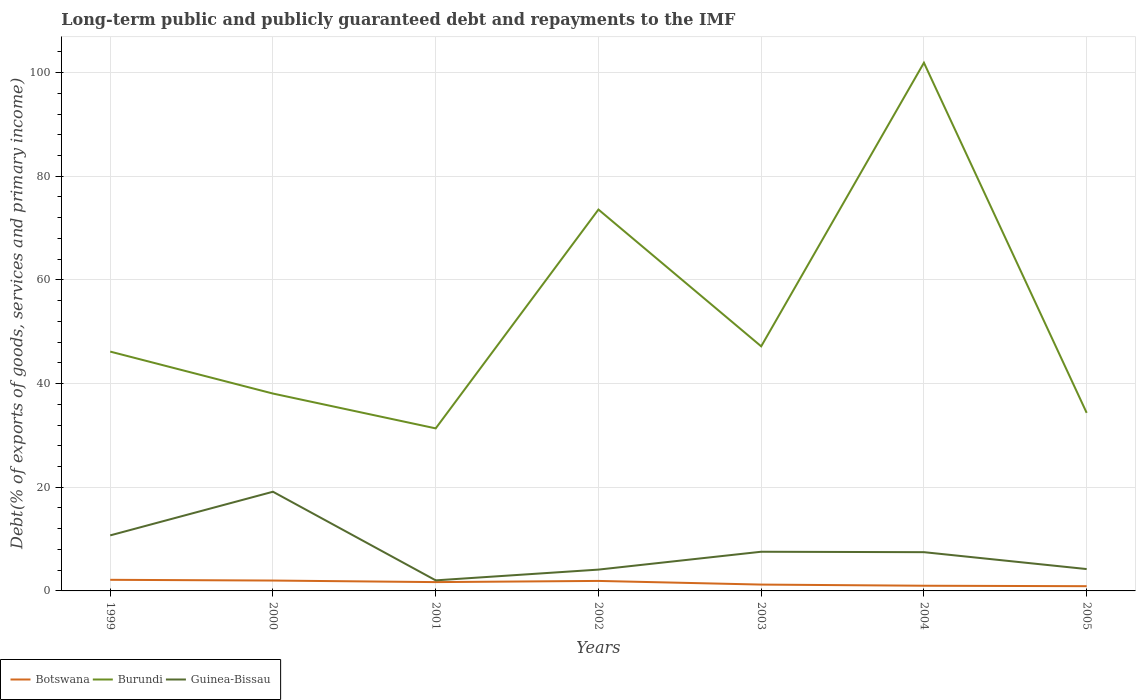Is the number of lines equal to the number of legend labels?
Keep it short and to the point. Yes. Across all years, what is the maximum debt and repayments in Burundi?
Keep it short and to the point. 31.35. In which year was the debt and repayments in Guinea-Bissau maximum?
Provide a short and direct response. 2001. What is the total debt and repayments in Burundi in the graph?
Your answer should be compact. 67.54. What is the difference between the highest and the second highest debt and repayments in Botswana?
Give a very brief answer. 1.23. What is the difference between the highest and the lowest debt and repayments in Burundi?
Keep it short and to the point. 2. What is the difference between two consecutive major ticks on the Y-axis?
Offer a terse response. 20. Where does the legend appear in the graph?
Provide a short and direct response. Bottom left. How many legend labels are there?
Ensure brevity in your answer.  3. What is the title of the graph?
Provide a succinct answer. Long-term public and publicly guaranteed debt and repayments to the IMF. Does "St. Vincent and the Grenadines" appear as one of the legend labels in the graph?
Your response must be concise. No. What is the label or title of the Y-axis?
Provide a short and direct response. Debt(% of exports of goods, services and primary income). What is the Debt(% of exports of goods, services and primary income) in Botswana in 1999?
Give a very brief answer. 2.14. What is the Debt(% of exports of goods, services and primary income) of Burundi in 1999?
Keep it short and to the point. 46.17. What is the Debt(% of exports of goods, services and primary income) in Guinea-Bissau in 1999?
Provide a short and direct response. 10.71. What is the Debt(% of exports of goods, services and primary income) in Botswana in 2000?
Give a very brief answer. 2. What is the Debt(% of exports of goods, services and primary income) in Burundi in 2000?
Give a very brief answer. 38.07. What is the Debt(% of exports of goods, services and primary income) of Guinea-Bissau in 2000?
Offer a very short reply. 19.13. What is the Debt(% of exports of goods, services and primary income) of Botswana in 2001?
Your response must be concise. 1.7. What is the Debt(% of exports of goods, services and primary income) of Burundi in 2001?
Your response must be concise. 31.35. What is the Debt(% of exports of goods, services and primary income) in Guinea-Bissau in 2001?
Offer a very short reply. 2.04. What is the Debt(% of exports of goods, services and primary income) of Botswana in 2002?
Your response must be concise. 1.93. What is the Debt(% of exports of goods, services and primary income) of Burundi in 2002?
Provide a short and direct response. 73.57. What is the Debt(% of exports of goods, services and primary income) of Guinea-Bissau in 2002?
Provide a succinct answer. 4.11. What is the Debt(% of exports of goods, services and primary income) of Botswana in 2003?
Your answer should be very brief. 1.22. What is the Debt(% of exports of goods, services and primary income) in Burundi in 2003?
Provide a short and direct response. 47.19. What is the Debt(% of exports of goods, services and primary income) in Guinea-Bissau in 2003?
Give a very brief answer. 7.56. What is the Debt(% of exports of goods, services and primary income) in Botswana in 2004?
Keep it short and to the point. 1. What is the Debt(% of exports of goods, services and primary income) of Burundi in 2004?
Make the answer very short. 101.89. What is the Debt(% of exports of goods, services and primary income) in Guinea-Bissau in 2004?
Your answer should be very brief. 7.47. What is the Debt(% of exports of goods, services and primary income) in Botswana in 2005?
Give a very brief answer. 0.91. What is the Debt(% of exports of goods, services and primary income) in Burundi in 2005?
Give a very brief answer. 34.35. What is the Debt(% of exports of goods, services and primary income) of Guinea-Bissau in 2005?
Provide a succinct answer. 4.22. Across all years, what is the maximum Debt(% of exports of goods, services and primary income) of Botswana?
Ensure brevity in your answer.  2.14. Across all years, what is the maximum Debt(% of exports of goods, services and primary income) of Burundi?
Your response must be concise. 101.89. Across all years, what is the maximum Debt(% of exports of goods, services and primary income) of Guinea-Bissau?
Your response must be concise. 19.13. Across all years, what is the minimum Debt(% of exports of goods, services and primary income) of Botswana?
Your answer should be very brief. 0.91. Across all years, what is the minimum Debt(% of exports of goods, services and primary income) in Burundi?
Keep it short and to the point. 31.35. Across all years, what is the minimum Debt(% of exports of goods, services and primary income) of Guinea-Bissau?
Your response must be concise. 2.04. What is the total Debt(% of exports of goods, services and primary income) of Botswana in the graph?
Your response must be concise. 10.91. What is the total Debt(% of exports of goods, services and primary income) of Burundi in the graph?
Your answer should be very brief. 372.59. What is the total Debt(% of exports of goods, services and primary income) of Guinea-Bissau in the graph?
Provide a short and direct response. 55.25. What is the difference between the Debt(% of exports of goods, services and primary income) in Botswana in 1999 and that in 2000?
Make the answer very short. 0.14. What is the difference between the Debt(% of exports of goods, services and primary income) of Burundi in 1999 and that in 2000?
Keep it short and to the point. 8.09. What is the difference between the Debt(% of exports of goods, services and primary income) of Guinea-Bissau in 1999 and that in 2000?
Offer a terse response. -8.42. What is the difference between the Debt(% of exports of goods, services and primary income) in Botswana in 1999 and that in 2001?
Offer a terse response. 0.44. What is the difference between the Debt(% of exports of goods, services and primary income) in Burundi in 1999 and that in 2001?
Make the answer very short. 14.81. What is the difference between the Debt(% of exports of goods, services and primary income) in Guinea-Bissau in 1999 and that in 2001?
Offer a terse response. 8.68. What is the difference between the Debt(% of exports of goods, services and primary income) in Botswana in 1999 and that in 2002?
Provide a short and direct response. 0.21. What is the difference between the Debt(% of exports of goods, services and primary income) of Burundi in 1999 and that in 2002?
Keep it short and to the point. -27.4. What is the difference between the Debt(% of exports of goods, services and primary income) of Guinea-Bissau in 1999 and that in 2002?
Offer a very short reply. 6.6. What is the difference between the Debt(% of exports of goods, services and primary income) in Botswana in 1999 and that in 2003?
Offer a very short reply. 0.92. What is the difference between the Debt(% of exports of goods, services and primary income) of Burundi in 1999 and that in 2003?
Provide a short and direct response. -1.02. What is the difference between the Debt(% of exports of goods, services and primary income) in Guinea-Bissau in 1999 and that in 2003?
Offer a very short reply. 3.16. What is the difference between the Debt(% of exports of goods, services and primary income) of Botswana in 1999 and that in 2004?
Ensure brevity in your answer.  1.14. What is the difference between the Debt(% of exports of goods, services and primary income) of Burundi in 1999 and that in 2004?
Your answer should be very brief. -55.72. What is the difference between the Debt(% of exports of goods, services and primary income) of Guinea-Bissau in 1999 and that in 2004?
Your answer should be very brief. 3.24. What is the difference between the Debt(% of exports of goods, services and primary income) of Botswana in 1999 and that in 2005?
Provide a short and direct response. 1.23. What is the difference between the Debt(% of exports of goods, services and primary income) in Burundi in 1999 and that in 2005?
Your answer should be compact. 11.82. What is the difference between the Debt(% of exports of goods, services and primary income) in Guinea-Bissau in 1999 and that in 2005?
Your answer should be compact. 6.5. What is the difference between the Debt(% of exports of goods, services and primary income) of Botswana in 2000 and that in 2001?
Provide a succinct answer. 0.3. What is the difference between the Debt(% of exports of goods, services and primary income) of Burundi in 2000 and that in 2001?
Your answer should be compact. 6.72. What is the difference between the Debt(% of exports of goods, services and primary income) of Guinea-Bissau in 2000 and that in 2001?
Your answer should be very brief. 17.1. What is the difference between the Debt(% of exports of goods, services and primary income) in Botswana in 2000 and that in 2002?
Your answer should be compact. 0.07. What is the difference between the Debt(% of exports of goods, services and primary income) of Burundi in 2000 and that in 2002?
Offer a terse response. -35.5. What is the difference between the Debt(% of exports of goods, services and primary income) of Guinea-Bissau in 2000 and that in 2002?
Your answer should be compact. 15.02. What is the difference between the Debt(% of exports of goods, services and primary income) in Botswana in 2000 and that in 2003?
Offer a terse response. 0.78. What is the difference between the Debt(% of exports of goods, services and primary income) of Burundi in 2000 and that in 2003?
Provide a short and direct response. -9.11. What is the difference between the Debt(% of exports of goods, services and primary income) in Guinea-Bissau in 2000 and that in 2003?
Provide a succinct answer. 11.58. What is the difference between the Debt(% of exports of goods, services and primary income) in Botswana in 2000 and that in 2004?
Your answer should be compact. 1. What is the difference between the Debt(% of exports of goods, services and primary income) in Burundi in 2000 and that in 2004?
Your response must be concise. -63.82. What is the difference between the Debt(% of exports of goods, services and primary income) of Guinea-Bissau in 2000 and that in 2004?
Provide a short and direct response. 11.66. What is the difference between the Debt(% of exports of goods, services and primary income) in Botswana in 2000 and that in 2005?
Provide a succinct answer. 1.09. What is the difference between the Debt(% of exports of goods, services and primary income) in Burundi in 2000 and that in 2005?
Provide a short and direct response. 3.72. What is the difference between the Debt(% of exports of goods, services and primary income) of Guinea-Bissau in 2000 and that in 2005?
Your answer should be very brief. 14.92. What is the difference between the Debt(% of exports of goods, services and primary income) of Botswana in 2001 and that in 2002?
Your answer should be very brief. -0.23. What is the difference between the Debt(% of exports of goods, services and primary income) in Burundi in 2001 and that in 2002?
Provide a succinct answer. -42.22. What is the difference between the Debt(% of exports of goods, services and primary income) in Guinea-Bissau in 2001 and that in 2002?
Ensure brevity in your answer.  -2.07. What is the difference between the Debt(% of exports of goods, services and primary income) in Botswana in 2001 and that in 2003?
Your response must be concise. 0.48. What is the difference between the Debt(% of exports of goods, services and primary income) of Burundi in 2001 and that in 2003?
Offer a terse response. -15.83. What is the difference between the Debt(% of exports of goods, services and primary income) in Guinea-Bissau in 2001 and that in 2003?
Your answer should be compact. -5.52. What is the difference between the Debt(% of exports of goods, services and primary income) in Botswana in 2001 and that in 2004?
Make the answer very short. 0.7. What is the difference between the Debt(% of exports of goods, services and primary income) of Burundi in 2001 and that in 2004?
Keep it short and to the point. -70.53. What is the difference between the Debt(% of exports of goods, services and primary income) of Guinea-Bissau in 2001 and that in 2004?
Keep it short and to the point. -5.44. What is the difference between the Debt(% of exports of goods, services and primary income) of Botswana in 2001 and that in 2005?
Provide a short and direct response. 0.79. What is the difference between the Debt(% of exports of goods, services and primary income) in Burundi in 2001 and that in 2005?
Offer a very short reply. -2.99. What is the difference between the Debt(% of exports of goods, services and primary income) of Guinea-Bissau in 2001 and that in 2005?
Your answer should be very brief. -2.18. What is the difference between the Debt(% of exports of goods, services and primary income) of Botswana in 2002 and that in 2003?
Offer a very short reply. 0.71. What is the difference between the Debt(% of exports of goods, services and primary income) of Burundi in 2002 and that in 2003?
Give a very brief answer. 26.39. What is the difference between the Debt(% of exports of goods, services and primary income) in Guinea-Bissau in 2002 and that in 2003?
Your response must be concise. -3.45. What is the difference between the Debt(% of exports of goods, services and primary income) of Botswana in 2002 and that in 2004?
Your answer should be very brief. 0.93. What is the difference between the Debt(% of exports of goods, services and primary income) of Burundi in 2002 and that in 2004?
Your answer should be very brief. -28.32. What is the difference between the Debt(% of exports of goods, services and primary income) of Guinea-Bissau in 2002 and that in 2004?
Provide a succinct answer. -3.36. What is the difference between the Debt(% of exports of goods, services and primary income) in Botswana in 2002 and that in 2005?
Make the answer very short. 1.02. What is the difference between the Debt(% of exports of goods, services and primary income) in Burundi in 2002 and that in 2005?
Your answer should be compact. 39.22. What is the difference between the Debt(% of exports of goods, services and primary income) in Guinea-Bissau in 2002 and that in 2005?
Your answer should be compact. -0.1. What is the difference between the Debt(% of exports of goods, services and primary income) in Botswana in 2003 and that in 2004?
Your answer should be very brief. 0.22. What is the difference between the Debt(% of exports of goods, services and primary income) of Burundi in 2003 and that in 2004?
Your answer should be very brief. -54.7. What is the difference between the Debt(% of exports of goods, services and primary income) of Guinea-Bissau in 2003 and that in 2004?
Offer a terse response. 0.08. What is the difference between the Debt(% of exports of goods, services and primary income) of Botswana in 2003 and that in 2005?
Ensure brevity in your answer.  0.31. What is the difference between the Debt(% of exports of goods, services and primary income) in Burundi in 2003 and that in 2005?
Offer a very short reply. 12.84. What is the difference between the Debt(% of exports of goods, services and primary income) in Guinea-Bissau in 2003 and that in 2005?
Your answer should be very brief. 3.34. What is the difference between the Debt(% of exports of goods, services and primary income) in Botswana in 2004 and that in 2005?
Keep it short and to the point. 0.09. What is the difference between the Debt(% of exports of goods, services and primary income) of Burundi in 2004 and that in 2005?
Offer a very short reply. 67.54. What is the difference between the Debt(% of exports of goods, services and primary income) in Guinea-Bissau in 2004 and that in 2005?
Your response must be concise. 3.26. What is the difference between the Debt(% of exports of goods, services and primary income) of Botswana in 1999 and the Debt(% of exports of goods, services and primary income) of Burundi in 2000?
Give a very brief answer. -35.93. What is the difference between the Debt(% of exports of goods, services and primary income) in Botswana in 1999 and the Debt(% of exports of goods, services and primary income) in Guinea-Bissau in 2000?
Your answer should be compact. -16.99. What is the difference between the Debt(% of exports of goods, services and primary income) of Burundi in 1999 and the Debt(% of exports of goods, services and primary income) of Guinea-Bissau in 2000?
Provide a short and direct response. 27.03. What is the difference between the Debt(% of exports of goods, services and primary income) of Botswana in 1999 and the Debt(% of exports of goods, services and primary income) of Burundi in 2001?
Give a very brief answer. -29.21. What is the difference between the Debt(% of exports of goods, services and primary income) of Botswana in 1999 and the Debt(% of exports of goods, services and primary income) of Guinea-Bissau in 2001?
Your answer should be compact. 0.1. What is the difference between the Debt(% of exports of goods, services and primary income) in Burundi in 1999 and the Debt(% of exports of goods, services and primary income) in Guinea-Bissau in 2001?
Provide a short and direct response. 44.13. What is the difference between the Debt(% of exports of goods, services and primary income) in Botswana in 1999 and the Debt(% of exports of goods, services and primary income) in Burundi in 2002?
Offer a very short reply. -71.43. What is the difference between the Debt(% of exports of goods, services and primary income) of Botswana in 1999 and the Debt(% of exports of goods, services and primary income) of Guinea-Bissau in 2002?
Provide a short and direct response. -1.97. What is the difference between the Debt(% of exports of goods, services and primary income) in Burundi in 1999 and the Debt(% of exports of goods, services and primary income) in Guinea-Bissau in 2002?
Offer a terse response. 42.06. What is the difference between the Debt(% of exports of goods, services and primary income) of Botswana in 1999 and the Debt(% of exports of goods, services and primary income) of Burundi in 2003?
Provide a succinct answer. -45.04. What is the difference between the Debt(% of exports of goods, services and primary income) of Botswana in 1999 and the Debt(% of exports of goods, services and primary income) of Guinea-Bissau in 2003?
Keep it short and to the point. -5.41. What is the difference between the Debt(% of exports of goods, services and primary income) of Burundi in 1999 and the Debt(% of exports of goods, services and primary income) of Guinea-Bissau in 2003?
Offer a terse response. 38.61. What is the difference between the Debt(% of exports of goods, services and primary income) in Botswana in 1999 and the Debt(% of exports of goods, services and primary income) in Burundi in 2004?
Your answer should be very brief. -99.75. What is the difference between the Debt(% of exports of goods, services and primary income) of Botswana in 1999 and the Debt(% of exports of goods, services and primary income) of Guinea-Bissau in 2004?
Ensure brevity in your answer.  -5.33. What is the difference between the Debt(% of exports of goods, services and primary income) of Burundi in 1999 and the Debt(% of exports of goods, services and primary income) of Guinea-Bissau in 2004?
Provide a succinct answer. 38.69. What is the difference between the Debt(% of exports of goods, services and primary income) of Botswana in 1999 and the Debt(% of exports of goods, services and primary income) of Burundi in 2005?
Your answer should be compact. -32.21. What is the difference between the Debt(% of exports of goods, services and primary income) of Botswana in 1999 and the Debt(% of exports of goods, services and primary income) of Guinea-Bissau in 2005?
Offer a terse response. -2.07. What is the difference between the Debt(% of exports of goods, services and primary income) in Burundi in 1999 and the Debt(% of exports of goods, services and primary income) in Guinea-Bissau in 2005?
Ensure brevity in your answer.  41.95. What is the difference between the Debt(% of exports of goods, services and primary income) of Botswana in 2000 and the Debt(% of exports of goods, services and primary income) of Burundi in 2001?
Your answer should be compact. -29.35. What is the difference between the Debt(% of exports of goods, services and primary income) in Botswana in 2000 and the Debt(% of exports of goods, services and primary income) in Guinea-Bissau in 2001?
Your response must be concise. -0.04. What is the difference between the Debt(% of exports of goods, services and primary income) in Burundi in 2000 and the Debt(% of exports of goods, services and primary income) in Guinea-Bissau in 2001?
Ensure brevity in your answer.  36.03. What is the difference between the Debt(% of exports of goods, services and primary income) in Botswana in 2000 and the Debt(% of exports of goods, services and primary income) in Burundi in 2002?
Ensure brevity in your answer.  -71.57. What is the difference between the Debt(% of exports of goods, services and primary income) in Botswana in 2000 and the Debt(% of exports of goods, services and primary income) in Guinea-Bissau in 2002?
Your answer should be very brief. -2.11. What is the difference between the Debt(% of exports of goods, services and primary income) of Burundi in 2000 and the Debt(% of exports of goods, services and primary income) of Guinea-Bissau in 2002?
Your answer should be compact. 33.96. What is the difference between the Debt(% of exports of goods, services and primary income) in Botswana in 2000 and the Debt(% of exports of goods, services and primary income) in Burundi in 2003?
Your response must be concise. -45.18. What is the difference between the Debt(% of exports of goods, services and primary income) in Botswana in 2000 and the Debt(% of exports of goods, services and primary income) in Guinea-Bissau in 2003?
Make the answer very short. -5.56. What is the difference between the Debt(% of exports of goods, services and primary income) of Burundi in 2000 and the Debt(% of exports of goods, services and primary income) of Guinea-Bissau in 2003?
Keep it short and to the point. 30.52. What is the difference between the Debt(% of exports of goods, services and primary income) in Botswana in 2000 and the Debt(% of exports of goods, services and primary income) in Burundi in 2004?
Offer a very short reply. -99.89. What is the difference between the Debt(% of exports of goods, services and primary income) in Botswana in 2000 and the Debt(% of exports of goods, services and primary income) in Guinea-Bissau in 2004?
Provide a short and direct response. -5.47. What is the difference between the Debt(% of exports of goods, services and primary income) in Burundi in 2000 and the Debt(% of exports of goods, services and primary income) in Guinea-Bissau in 2004?
Offer a terse response. 30.6. What is the difference between the Debt(% of exports of goods, services and primary income) in Botswana in 2000 and the Debt(% of exports of goods, services and primary income) in Burundi in 2005?
Provide a short and direct response. -32.35. What is the difference between the Debt(% of exports of goods, services and primary income) of Botswana in 2000 and the Debt(% of exports of goods, services and primary income) of Guinea-Bissau in 2005?
Give a very brief answer. -2.21. What is the difference between the Debt(% of exports of goods, services and primary income) of Burundi in 2000 and the Debt(% of exports of goods, services and primary income) of Guinea-Bissau in 2005?
Keep it short and to the point. 33.86. What is the difference between the Debt(% of exports of goods, services and primary income) in Botswana in 2001 and the Debt(% of exports of goods, services and primary income) in Burundi in 2002?
Give a very brief answer. -71.87. What is the difference between the Debt(% of exports of goods, services and primary income) of Botswana in 2001 and the Debt(% of exports of goods, services and primary income) of Guinea-Bissau in 2002?
Ensure brevity in your answer.  -2.41. What is the difference between the Debt(% of exports of goods, services and primary income) in Burundi in 2001 and the Debt(% of exports of goods, services and primary income) in Guinea-Bissau in 2002?
Offer a very short reply. 27.24. What is the difference between the Debt(% of exports of goods, services and primary income) in Botswana in 2001 and the Debt(% of exports of goods, services and primary income) in Burundi in 2003?
Give a very brief answer. -45.48. What is the difference between the Debt(% of exports of goods, services and primary income) of Botswana in 2001 and the Debt(% of exports of goods, services and primary income) of Guinea-Bissau in 2003?
Keep it short and to the point. -5.86. What is the difference between the Debt(% of exports of goods, services and primary income) of Burundi in 2001 and the Debt(% of exports of goods, services and primary income) of Guinea-Bissau in 2003?
Offer a terse response. 23.8. What is the difference between the Debt(% of exports of goods, services and primary income) in Botswana in 2001 and the Debt(% of exports of goods, services and primary income) in Burundi in 2004?
Your response must be concise. -100.19. What is the difference between the Debt(% of exports of goods, services and primary income) in Botswana in 2001 and the Debt(% of exports of goods, services and primary income) in Guinea-Bissau in 2004?
Make the answer very short. -5.77. What is the difference between the Debt(% of exports of goods, services and primary income) in Burundi in 2001 and the Debt(% of exports of goods, services and primary income) in Guinea-Bissau in 2004?
Keep it short and to the point. 23.88. What is the difference between the Debt(% of exports of goods, services and primary income) of Botswana in 2001 and the Debt(% of exports of goods, services and primary income) of Burundi in 2005?
Your answer should be compact. -32.65. What is the difference between the Debt(% of exports of goods, services and primary income) of Botswana in 2001 and the Debt(% of exports of goods, services and primary income) of Guinea-Bissau in 2005?
Offer a very short reply. -2.52. What is the difference between the Debt(% of exports of goods, services and primary income) in Burundi in 2001 and the Debt(% of exports of goods, services and primary income) in Guinea-Bissau in 2005?
Ensure brevity in your answer.  27.14. What is the difference between the Debt(% of exports of goods, services and primary income) in Botswana in 2002 and the Debt(% of exports of goods, services and primary income) in Burundi in 2003?
Offer a terse response. -45.26. What is the difference between the Debt(% of exports of goods, services and primary income) of Botswana in 2002 and the Debt(% of exports of goods, services and primary income) of Guinea-Bissau in 2003?
Your answer should be compact. -5.63. What is the difference between the Debt(% of exports of goods, services and primary income) of Burundi in 2002 and the Debt(% of exports of goods, services and primary income) of Guinea-Bissau in 2003?
Your response must be concise. 66.01. What is the difference between the Debt(% of exports of goods, services and primary income) of Botswana in 2002 and the Debt(% of exports of goods, services and primary income) of Burundi in 2004?
Provide a short and direct response. -99.96. What is the difference between the Debt(% of exports of goods, services and primary income) of Botswana in 2002 and the Debt(% of exports of goods, services and primary income) of Guinea-Bissau in 2004?
Your response must be concise. -5.55. What is the difference between the Debt(% of exports of goods, services and primary income) of Burundi in 2002 and the Debt(% of exports of goods, services and primary income) of Guinea-Bissau in 2004?
Your answer should be very brief. 66.1. What is the difference between the Debt(% of exports of goods, services and primary income) of Botswana in 2002 and the Debt(% of exports of goods, services and primary income) of Burundi in 2005?
Ensure brevity in your answer.  -32.42. What is the difference between the Debt(% of exports of goods, services and primary income) in Botswana in 2002 and the Debt(% of exports of goods, services and primary income) in Guinea-Bissau in 2005?
Ensure brevity in your answer.  -2.29. What is the difference between the Debt(% of exports of goods, services and primary income) of Burundi in 2002 and the Debt(% of exports of goods, services and primary income) of Guinea-Bissau in 2005?
Your answer should be compact. 69.35. What is the difference between the Debt(% of exports of goods, services and primary income) in Botswana in 2003 and the Debt(% of exports of goods, services and primary income) in Burundi in 2004?
Provide a short and direct response. -100.66. What is the difference between the Debt(% of exports of goods, services and primary income) of Botswana in 2003 and the Debt(% of exports of goods, services and primary income) of Guinea-Bissau in 2004?
Make the answer very short. -6.25. What is the difference between the Debt(% of exports of goods, services and primary income) in Burundi in 2003 and the Debt(% of exports of goods, services and primary income) in Guinea-Bissau in 2004?
Offer a terse response. 39.71. What is the difference between the Debt(% of exports of goods, services and primary income) in Botswana in 2003 and the Debt(% of exports of goods, services and primary income) in Burundi in 2005?
Give a very brief answer. -33.12. What is the difference between the Debt(% of exports of goods, services and primary income) of Botswana in 2003 and the Debt(% of exports of goods, services and primary income) of Guinea-Bissau in 2005?
Provide a short and direct response. -2.99. What is the difference between the Debt(% of exports of goods, services and primary income) of Burundi in 2003 and the Debt(% of exports of goods, services and primary income) of Guinea-Bissau in 2005?
Offer a very short reply. 42.97. What is the difference between the Debt(% of exports of goods, services and primary income) in Botswana in 2004 and the Debt(% of exports of goods, services and primary income) in Burundi in 2005?
Provide a succinct answer. -33.35. What is the difference between the Debt(% of exports of goods, services and primary income) in Botswana in 2004 and the Debt(% of exports of goods, services and primary income) in Guinea-Bissau in 2005?
Keep it short and to the point. -3.21. What is the difference between the Debt(% of exports of goods, services and primary income) of Burundi in 2004 and the Debt(% of exports of goods, services and primary income) of Guinea-Bissau in 2005?
Give a very brief answer. 97.67. What is the average Debt(% of exports of goods, services and primary income) in Botswana per year?
Provide a succinct answer. 1.56. What is the average Debt(% of exports of goods, services and primary income) in Burundi per year?
Ensure brevity in your answer.  53.23. What is the average Debt(% of exports of goods, services and primary income) in Guinea-Bissau per year?
Your answer should be very brief. 7.89. In the year 1999, what is the difference between the Debt(% of exports of goods, services and primary income) of Botswana and Debt(% of exports of goods, services and primary income) of Burundi?
Ensure brevity in your answer.  -44.02. In the year 1999, what is the difference between the Debt(% of exports of goods, services and primary income) of Botswana and Debt(% of exports of goods, services and primary income) of Guinea-Bissau?
Provide a succinct answer. -8.57. In the year 1999, what is the difference between the Debt(% of exports of goods, services and primary income) in Burundi and Debt(% of exports of goods, services and primary income) in Guinea-Bissau?
Offer a terse response. 35.45. In the year 2000, what is the difference between the Debt(% of exports of goods, services and primary income) in Botswana and Debt(% of exports of goods, services and primary income) in Burundi?
Offer a terse response. -36.07. In the year 2000, what is the difference between the Debt(% of exports of goods, services and primary income) of Botswana and Debt(% of exports of goods, services and primary income) of Guinea-Bissau?
Offer a very short reply. -17.13. In the year 2000, what is the difference between the Debt(% of exports of goods, services and primary income) of Burundi and Debt(% of exports of goods, services and primary income) of Guinea-Bissau?
Your answer should be compact. 18.94. In the year 2001, what is the difference between the Debt(% of exports of goods, services and primary income) of Botswana and Debt(% of exports of goods, services and primary income) of Burundi?
Your response must be concise. -29.65. In the year 2001, what is the difference between the Debt(% of exports of goods, services and primary income) in Botswana and Debt(% of exports of goods, services and primary income) in Guinea-Bissau?
Offer a very short reply. -0.34. In the year 2001, what is the difference between the Debt(% of exports of goods, services and primary income) in Burundi and Debt(% of exports of goods, services and primary income) in Guinea-Bissau?
Offer a terse response. 29.32. In the year 2002, what is the difference between the Debt(% of exports of goods, services and primary income) of Botswana and Debt(% of exports of goods, services and primary income) of Burundi?
Offer a very short reply. -71.64. In the year 2002, what is the difference between the Debt(% of exports of goods, services and primary income) of Botswana and Debt(% of exports of goods, services and primary income) of Guinea-Bissau?
Your answer should be compact. -2.18. In the year 2002, what is the difference between the Debt(% of exports of goods, services and primary income) of Burundi and Debt(% of exports of goods, services and primary income) of Guinea-Bissau?
Give a very brief answer. 69.46. In the year 2003, what is the difference between the Debt(% of exports of goods, services and primary income) in Botswana and Debt(% of exports of goods, services and primary income) in Burundi?
Provide a succinct answer. -45.96. In the year 2003, what is the difference between the Debt(% of exports of goods, services and primary income) of Botswana and Debt(% of exports of goods, services and primary income) of Guinea-Bissau?
Keep it short and to the point. -6.33. In the year 2003, what is the difference between the Debt(% of exports of goods, services and primary income) of Burundi and Debt(% of exports of goods, services and primary income) of Guinea-Bissau?
Keep it short and to the point. 39.63. In the year 2004, what is the difference between the Debt(% of exports of goods, services and primary income) of Botswana and Debt(% of exports of goods, services and primary income) of Burundi?
Give a very brief answer. -100.89. In the year 2004, what is the difference between the Debt(% of exports of goods, services and primary income) of Botswana and Debt(% of exports of goods, services and primary income) of Guinea-Bissau?
Your response must be concise. -6.47. In the year 2004, what is the difference between the Debt(% of exports of goods, services and primary income) in Burundi and Debt(% of exports of goods, services and primary income) in Guinea-Bissau?
Your response must be concise. 94.41. In the year 2005, what is the difference between the Debt(% of exports of goods, services and primary income) of Botswana and Debt(% of exports of goods, services and primary income) of Burundi?
Make the answer very short. -33.44. In the year 2005, what is the difference between the Debt(% of exports of goods, services and primary income) of Botswana and Debt(% of exports of goods, services and primary income) of Guinea-Bissau?
Offer a very short reply. -3.3. In the year 2005, what is the difference between the Debt(% of exports of goods, services and primary income) in Burundi and Debt(% of exports of goods, services and primary income) in Guinea-Bissau?
Provide a succinct answer. 30.13. What is the ratio of the Debt(% of exports of goods, services and primary income) of Botswana in 1999 to that in 2000?
Your answer should be compact. 1.07. What is the ratio of the Debt(% of exports of goods, services and primary income) of Burundi in 1999 to that in 2000?
Your answer should be very brief. 1.21. What is the ratio of the Debt(% of exports of goods, services and primary income) of Guinea-Bissau in 1999 to that in 2000?
Offer a terse response. 0.56. What is the ratio of the Debt(% of exports of goods, services and primary income) of Botswana in 1999 to that in 2001?
Offer a terse response. 1.26. What is the ratio of the Debt(% of exports of goods, services and primary income) in Burundi in 1999 to that in 2001?
Make the answer very short. 1.47. What is the ratio of the Debt(% of exports of goods, services and primary income) of Guinea-Bissau in 1999 to that in 2001?
Your answer should be very brief. 5.26. What is the ratio of the Debt(% of exports of goods, services and primary income) in Botswana in 1999 to that in 2002?
Your answer should be compact. 1.11. What is the ratio of the Debt(% of exports of goods, services and primary income) of Burundi in 1999 to that in 2002?
Offer a very short reply. 0.63. What is the ratio of the Debt(% of exports of goods, services and primary income) in Guinea-Bissau in 1999 to that in 2002?
Keep it short and to the point. 2.61. What is the ratio of the Debt(% of exports of goods, services and primary income) of Botswana in 1999 to that in 2003?
Your response must be concise. 1.75. What is the ratio of the Debt(% of exports of goods, services and primary income) of Burundi in 1999 to that in 2003?
Your response must be concise. 0.98. What is the ratio of the Debt(% of exports of goods, services and primary income) of Guinea-Bissau in 1999 to that in 2003?
Offer a terse response. 1.42. What is the ratio of the Debt(% of exports of goods, services and primary income) in Botswana in 1999 to that in 2004?
Give a very brief answer. 2.14. What is the ratio of the Debt(% of exports of goods, services and primary income) of Burundi in 1999 to that in 2004?
Provide a succinct answer. 0.45. What is the ratio of the Debt(% of exports of goods, services and primary income) of Guinea-Bissau in 1999 to that in 2004?
Your response must be concise. 1.43. What is the ratio of the Debt(% of exports of goods, services and primary income) of Botswana in 1999 to that in 2005?
Make the answer very short. 2.35. What is the ratio of the Debt(% of exports of goods, services and primary income) of Burundi in 1999 to that in 2005?
Make the answer very short. 1.34. What is the ratio of the Debt(% of exports of goods, services and primary income) in Guinea-Bissau in 1999 to that in 2005?
Provide a succinct answer. 2.54. What is the ratio of the Debt(% of exports of goods, services and primary income) of Botswana in 2000 to that in 2001?
Provide a short and direct response. 1.18. What is the ratio of the Debt(% of exports of goods, services and primary income) of Burundi in 2000 to that in 2001?
Provide a short and direct response. 1.21. What is the ratio of the Debt(% of exports of goods, services and primary income) of Guinea-Bissau in 2000 to that in 2001?
Offer a very short reply. 9.39. What is the ratio of the Debt(% of exports of goods, services and primary income) of Botswana in 2000 to that in 2002?
Ensure brevity in your answer.  1.04. What is the ratio of the Debt(% of exports of goods, services and primary income) in Burundi in 2000 to that in 2002?
Keep it short and to the point. 0.52. What is the ratio of the Debt(% of exports of goods, services and primary income) in Guinea-Bissau in 2000 to that in 2002?
Provide a short and direct response. 4.65. What is the ratio of the Debt(% of exports of goods, services and primary income) in Botswana in 2000 to that in 2003?
Your answer should be very brief. 1.63. What is the ratio of the Debt(% of exports of goods, services and primary income) of Burundi in 2000 to that in 2003?
Your answer should be compact. 0.81. What is the ratio of the Debt(% of exports of goods, services and primary income) of Guinea-Bissau in 2000 to that in 2003?
Your answer should be very brief. 2.53. What is the ratio of the Debt(% of exports of goods, services and primary income) of Botswana in 2000 to that in 2004?
Provide a succinct answer. 2. What is the ratio of the Debt(% of exports of goods, services and primary income) of Burundi in 2000 to that in 2004?
Provide a succinct answer. 0.37. What is the ratio of the Debt(% of exports of goods, services and primary income) of Guinea-Bissau in 2000 to that in 2004?
Provide a succinct answer. 2.56. What is the ratio of the Debt(% of exports of goods, services and primary income) in Botswana in 2000 to that in 2005?
Your answer should be compact. 2.19. What is the ratio of the Debt(% of exports of goods, services and primary income) in Burundi in 2000 to that in 2005?
Make the answer very short. 1.11. What is the ratio of the Debt(% of exports of goods, services and primary income) in Guinea-Bissau in 2000 to that in 2005?
Offer a terse response. 4.54. What is the ratio of the Debt(% of exports of goods, services and primary income) of Botswana in 2001 to that in 2002?
Make the answer very short. 0.88. What is the ratio of the Debt(% of exports of goods, services and primary income) in Burundi in 2001 to that in 2002?
Offer a terse response. 0.43. What is the ratio of the Debt(% of exports of goods, services and primary income) in Guinea-Bissau in 2001 to that in 2002?
Your answer should be compact. 0.5. What is the ratio of the Debt(% of exports of goods, services and primary income) in Botswana in 2001 to that in 2003?
Give a very brief answer. 1.39. What is the ratio of the Debt(% of exports of goods, services and primary income) of Burundi in 2001 to that in 2003?
Ensure brevity in your answer.  0.66. What is the ratio of the Debt(% of exports of goods, services and primary income) of Guinea-Bissau in 2001 to that in 2003?
Your answer should be very brief. 0.27. What is the ratio of the Debt(% of exports of goods, services and primary income) in Botswana in 2001 to that in 2004?
Ensure brevity in your answer.  1.7. What is the ratio of the Debt(% of exports of goods, services and primary income) of Burundi in 2001 to that in 2004?
Your answer should be very brief. 0.31. What is the ratio of the Debt(% of exports of goods, services and primary income) of Guinea-Bissau in 2001 to that in 2004?
Keep it short and to the point. 0.27. What is the ratio of the Debt(% of exports of goods, services and primary income) of Botswana in 2001 to that in 2005?
Make the answer very short. 1.86. What is the ratio of the Debt(% of exports of goods, services and primary income) in Burundi in 2001 to that in 2005?
Offer a terse response. 0.91. What is the ratio of the Debt(% of exports of goods, services and primary income) of Guinea-Bissau in 2001 to that in 2005?
Your response must be concise. 0.48. What is the ratio of the Debt(% of exports of goods, services and primary income) of Botswana in 2002 to that in 2003?
Keep it short and to the point. 1.58. What is the ratio of the Debt(% of exports of goods, services and primary income) in Burundi in 2002 to that in 2003?
Ensure brevity in your answer.  1.56. What is the ratio of the Debt(% of exports of goods, services and primary income) in Guinea-Bissau in 2002 to that in 2003?
Your answer should be very brief. 0.54. What is the ratio of the Debt(% of exports of goods, services and primary income) in Botswana in 2002 to that in 2004?
Ensure brevity in your answer.  1.93. What is the ratio of the Debt(% of exports of goods, services and primary income) of Burundi in 2002 to that in 2004?
Your response must be concise. 0.72. What is the ratio of the Debt(% of exports of goods, services and primary income) of Guinea-Bissau in 2002 to that in 2004?
Provide a short and direct response. 0.55. What is the ratio of the Debt(% of exports of goods, services and primary income) in Botswana in 2002 to that in 2005?
Offer a very short reply. 2.11. What is the ratio of the Debt(% of exports of goods, services and primary income) of Burundi in 2002 to that in 2005?
Provide a short and direct response. 2.14. What is the ratio of the Debt(% of exports of goods, services and primary income) of Guinea-Bissau in 2002 to that in 2005?
Ensure brevity in your answer.  0.98. What is the ratio of the Debt(% of exports of goods, services and primary income) in Botswana in 2003 to that in 2004?
Provide a succinct answer. 1.22. What is the ratio of the Debt(% of exports of goods, services and primary income) of Burundi in 2003 to that in 2004?
Make the answer very short. 0.46. What is the ratio of the Debt(% of exports of goods, services and primary income) in Botswana in 2003 to that in 2005?
Ensure brevity in your answer.  1.34. What is the ratio of the Debt(% of exports of goods, services and primary income) in Burundi in 2003 to that in 2005?
Make the answer very short. 1.37. What is the ratio of the Debt(% of exports of goods, services and primary income) of Guinea-Bissau in 2003 to that in 2005?
Make the answer very short. 1.79. What is the ratio of the Debt(% of exports of goods, services and primary income) of Botswana in 2004 to that in 2005?
Your response must be concise. 1.1. What is the ratio of the Debt(% of exports of goods, services and primary income) in Burundi in 2004 to that in 2005?
Offer a terse response. 2.97. What is the ratio of the Debt(% of exports of goods, services and primary income) in Guinea-Bissau in 2004 to that in 2005?
Provide a succinct answer. 1.77. What is the difference between the highest and the second highest Debt(% of exports of goods, services and primary income) in Botswana?
Keep it short and to the point. 0.14. What is the difference between the highest and the second highest Debt(% of exports of goods, services and primary income) in Burundi?
Provide a succinct answer. 28.32. What is the difference between the highest and the second highest Debt(% of exports of goods, services and primary income) in Guinea-Bissau?
Your answer should be compact. 8.42. What is the difference between the highest and the lowest Debt(% of exports of goods, services and primary income) of Botswana?
Keep it short and to the point. 1.23. What is the difference between the highest and the lowest Debt(% of exports of goods, services and primary income) in Burundi?
Your answer should be very brief. 70.53. What is the difference between the highest and the lowest Debt(% of exports of goods, services and primary income) of Guinea-Bissau?
Ensure brevity in your answer.  17.1. 